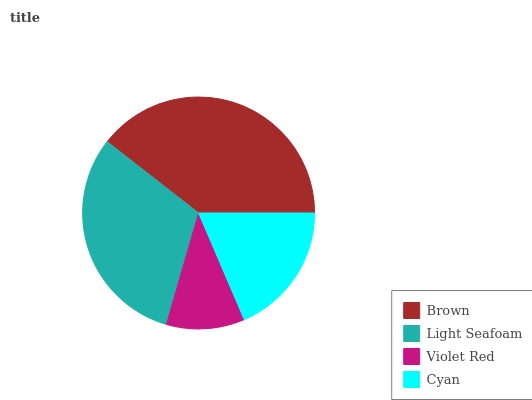Is Violet Red the minimum?
Answer yes or no. Yes. Is Brown the maximum?
Answer yes or no. Yes. Is Light Seafoam the minimum?
Answer yes or no. No. Is Light Seafoam the maximum?
Answer yes or no. No. Is Brown greater than Light Seafoam?
Answer yes or no. Yes. Is Light Seafoam less than Brown?
Answer yes or no. Yes. Is Light Seafoam greater than Brown?
Answer yes or no. No. Is Brown less than Light Seafoam?
Answer yes or no. No. Is Light Seafoam the high median?
Answer yes or no. Yes. Is Cyan the low median?
Answer yes or no. Yes. Is Brown the high median?
Answer yes or no. No. Is Brown the low median?
Answer yes or no. No. 